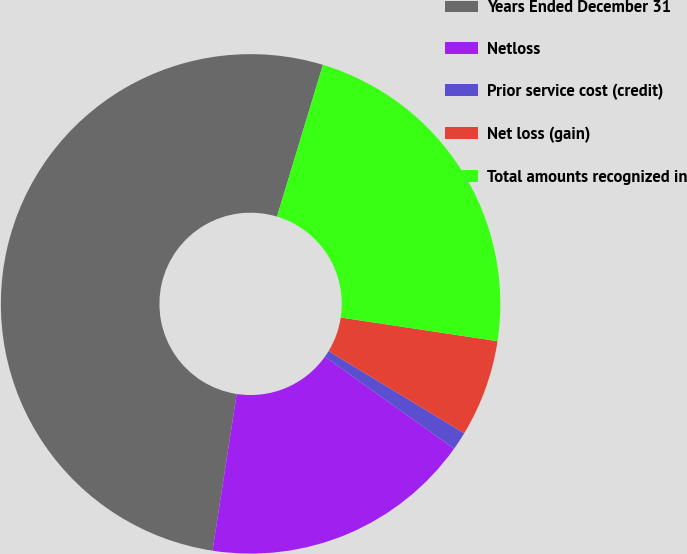<chart> <loc_0><loc_0><loc_500><loc_500><pie_chart><fcel>Years Ended December 31<fcel>Netloss<fcel>Prior service cost (credit)<fcel>Net loss (gain)<fcel>Total amounts recognized in<nl><fcel>52.24%<fcel>17.6%<fcel>1.17%<fcel>6.28%<fcel>22.71%<nl></chart> 